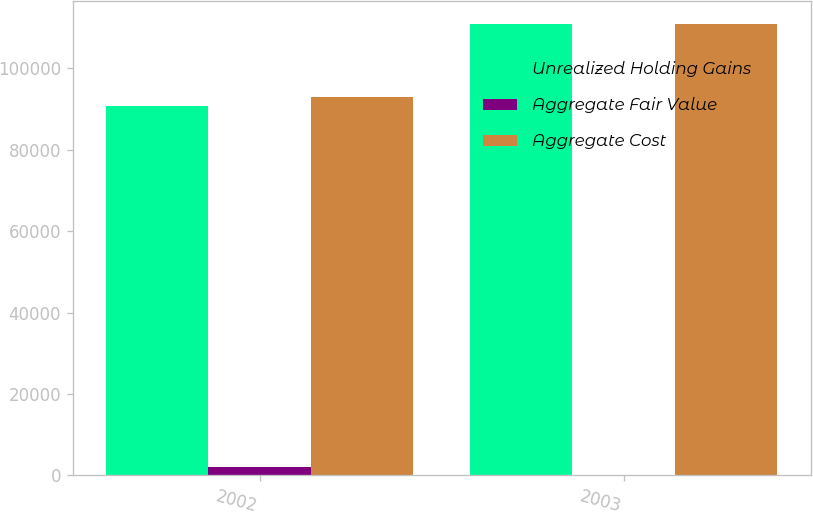Convert chart. <chart><loc_0><loc_0><loc_500><loc_500><stacked_bar_chart><ecel><fcel>2002<fcel>2003<nl><fcel>Unrealized Holding Gains<fcel>90888<fcel>110822<nl><fcel>Aggregate Fair Value<fcel>2020<fcel>140<nl><fcel>Aggregate Cost<fcel>92908<fcel>110962<nl></chart> 